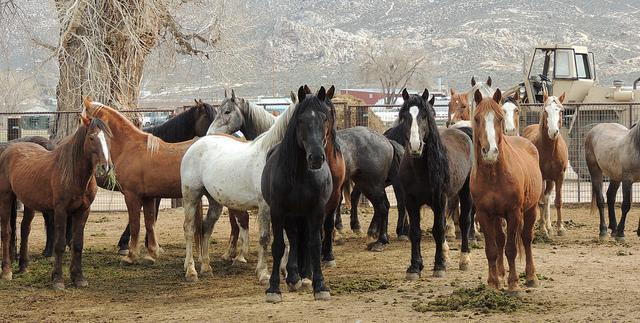What is the name of the fenced off area for these horses?
Indicate the correct response and explain using: 'Answer: answer
Rationale: rationale.'
Options: Corral, dirt road, parking lot, stage. Answer: corral.
Rationale: Horses reside in that field with fences. 